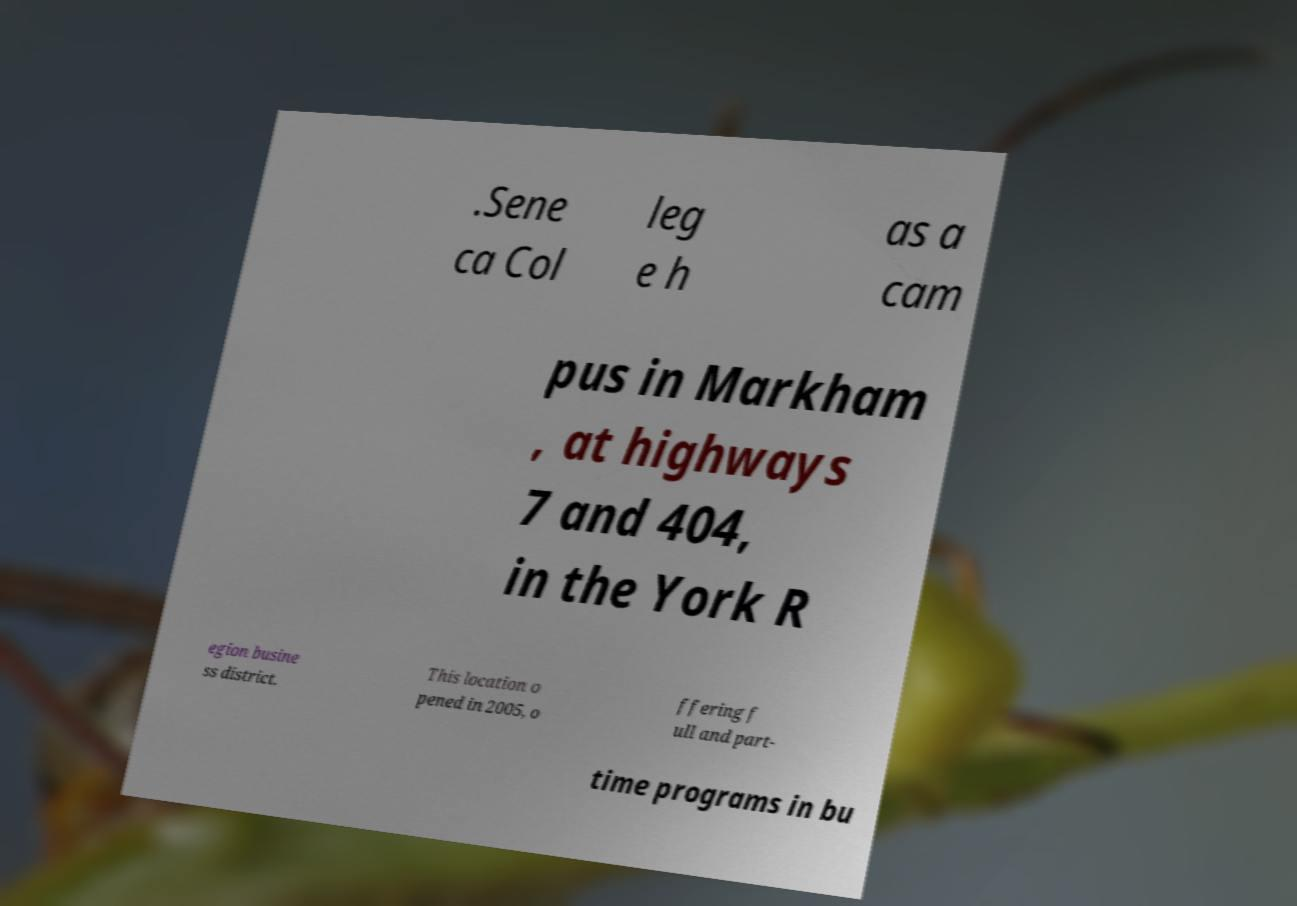Please identify and transcribe the text found in this image. .Sene ca Col leg e h as a cam pus in Markham , at highways 7 and 404, in the York R egion busine ss district. This location o pened in 2005, o ffering f ull and part- time programs in bu 